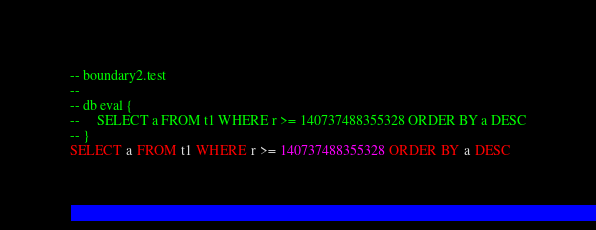<code> <loc_0><loc_0><loc_500><loc_500><_SQL_>-- boundary2.test
-- 
-- db eval {
--     SELECT a FROM t1 WHERE r >= 140737488355328 ORDER BY a DESC
-- }
SELECT a FROM t1 WHERE r >= 140737488355328 ORDER BY a DESC</code> 